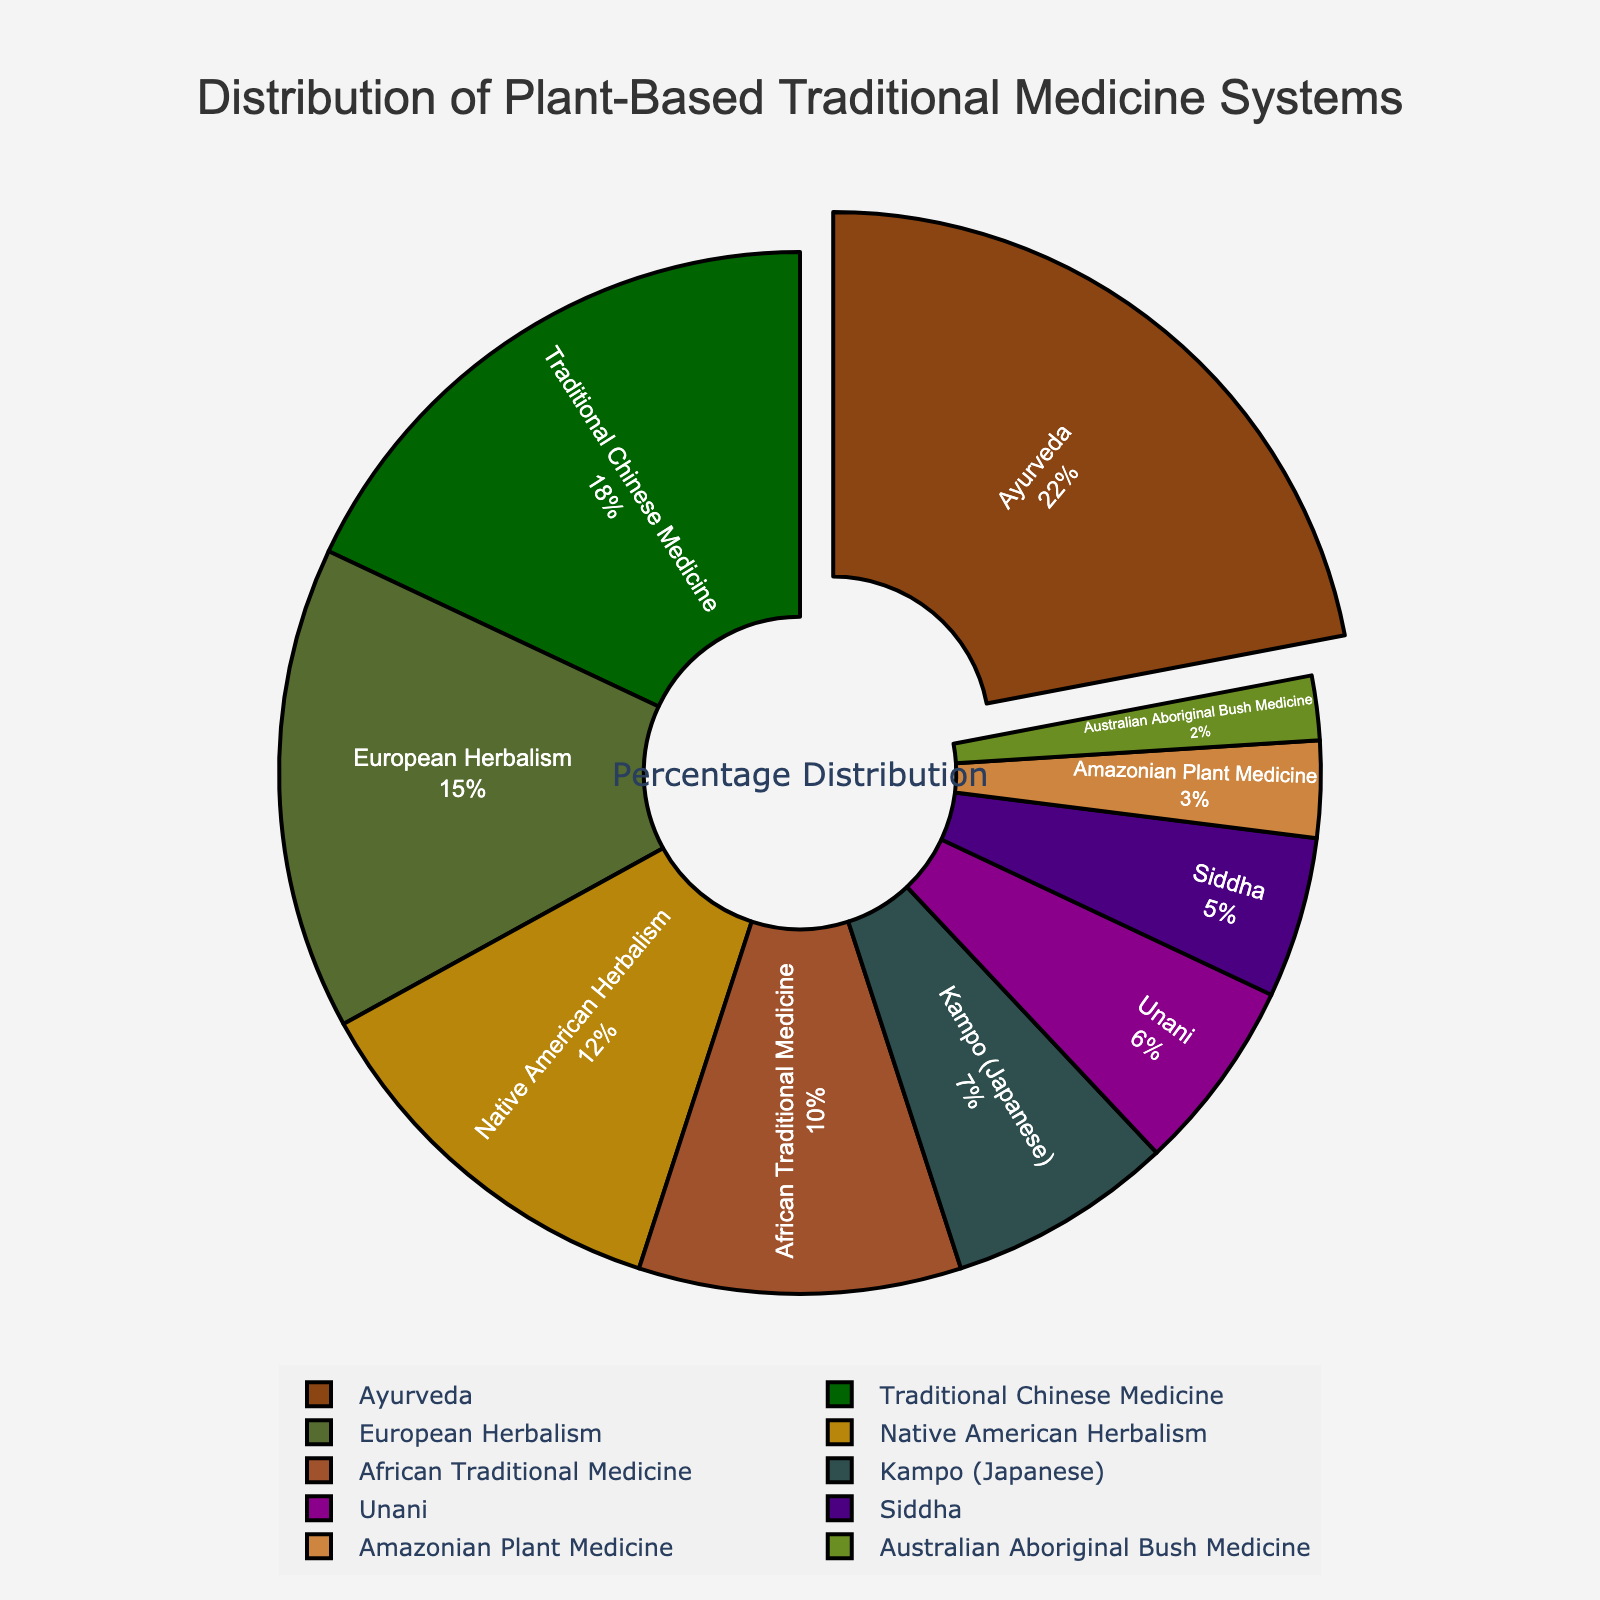What is the most common plant-based traditional medicine system represented in the pie chart? The largest section of the pie chart is pulled out slightly, indicating the most common system. It is labeled "Ayurveda" with 22%.
Answer: Ayurveda Which two systems have the closest percentage distribution? By comparing the percentages visually, European Herbalism (15%) and Traditional Chinese Medicine (18%) are the closest pairs with a difference of only 3 percentage points.
Answer: European Herbalism and Traditional Chinese Medicine How much larger is the percentage of Ayurveda compared to Unani? The pie chart shows Ayurveda at 22% and Unani at 6%. The difference is calculated as 22% - 6% = 16%.
Answer: 16% What is the combined percentage of African Traditional Medicine and Native American Herbalism? African Traditional Medicine is 10% and Native American Herbalism is 12%. The sum is 10% + 12% = 22%.
Answer: 22% Which systems make up less than 5% each of the total distribution? The pie chart labels less than 5% as Amazonian Plant Medicine (3%) and Australian Aboriginal Bush Medicine (2%).
Answer: Amazonian Plant Medicine and Australian Aboriginal Bush Medicine Are there more traditional medicine systems above 10% or below 10% in percentage distribution? Count the systems above 10%: Ayurveda (22%), Traditional Chinese Medicine (18%), Native American Herbalism (12%), and European Herbalism (15%) = 4 systems. Below 10%: African Traditional Medicine (10%), Kampo (7%), Unani (6%), Siddha (5%), Amazonian Plant Medicine (3%), Australian Aboriginal Bush Medicine (2%) = 6 systems.
Answer: Below 10% Which traditional medicine systems are represented by colors darker than brown? On the pie chart, darker than brown colors typically include shades of green and purple. This includes Traditional Chinese Medicine (dark green), Native American Herbalism (golden-brown), European Herbalism (dark olive green), and Unani (dark purple).
Answer: Traditional Chinese Medicine, Native American Herbalism, European Herbalism, and Unani What percentage difference exists between the smallest and largest segment? The smallest segment, Australian Aboriginal Bush Medicine, is 2%. The largest segment, Ayurveda, is 22%. The difference is 22% - 2% = 20%.
Answer: 20% What is the average percentage distribution of the Kampo and Siddha systems? Kampo is 7% and Siddha is 5%. The average is calculated as (7% + 5%) / 2 = 6%.
Answer: 6% If African Traditional Medicine were to increase by 5 percentage points, how would its new percentage compare to European Herbalism? African Traditional Medicine is 10%, and with a 5% increase, it would be 10% + 5% = 15%, which matches European Herbalism's current 15%.
Answer: Equal to European Herbalism 